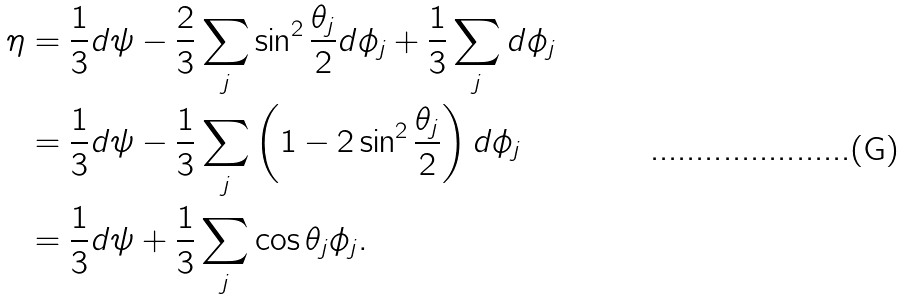Convert formula to latex. <formula><loc_0><loc_0><loc_500><loc_500>\eta & = \frac { 1 } { 3 } d \psi - \frac { 2 } { 3 } \sum _ { j } \sin ^ { 2 } \frac { \theta _ { j } } { 2 } d \phi _ { j } + \frac { 1 } { 3 } \sum _ { j } d \phi _ { j } \\ & = \frac { 1 } { 3 } d \psi - \frac { 1 } { 3 } \sum _ { j } \left ( 1 - 2 \sin ^ { 2 } \frac { \theta _ { j } } { 2 } \right ) d \phi _ { j } \\ & = \frac { 1 } { 3 } d \psi + \frac { 1 } { 3 } \sum _ { j } \cos \theta _ { j } \phi _ { j } .</formula> 